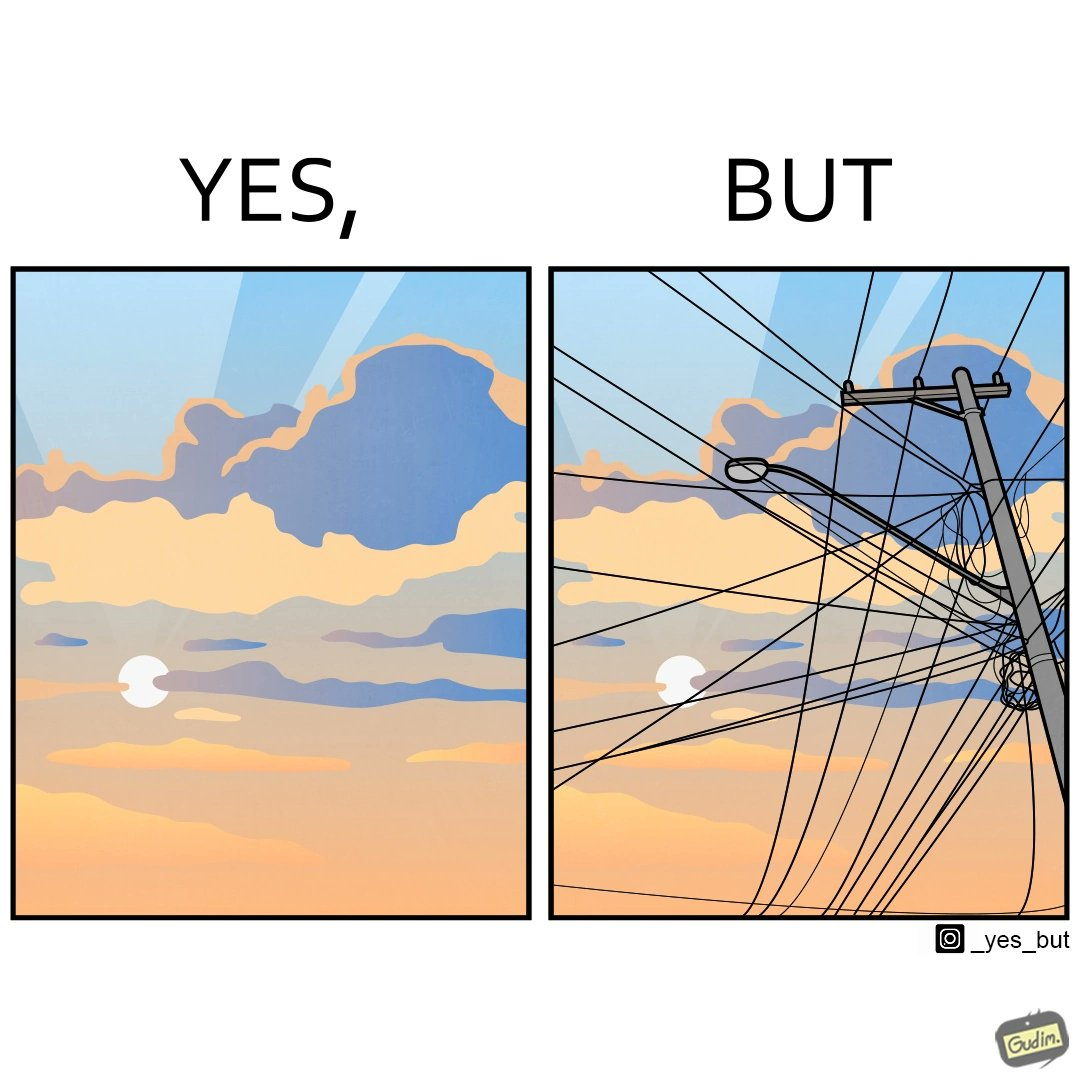Describe what you see in the left and right parts of this image. In the left part of the image: a clear sky with sun and clouds In the right part of the image: an electricity pole with a lot of wires over it 